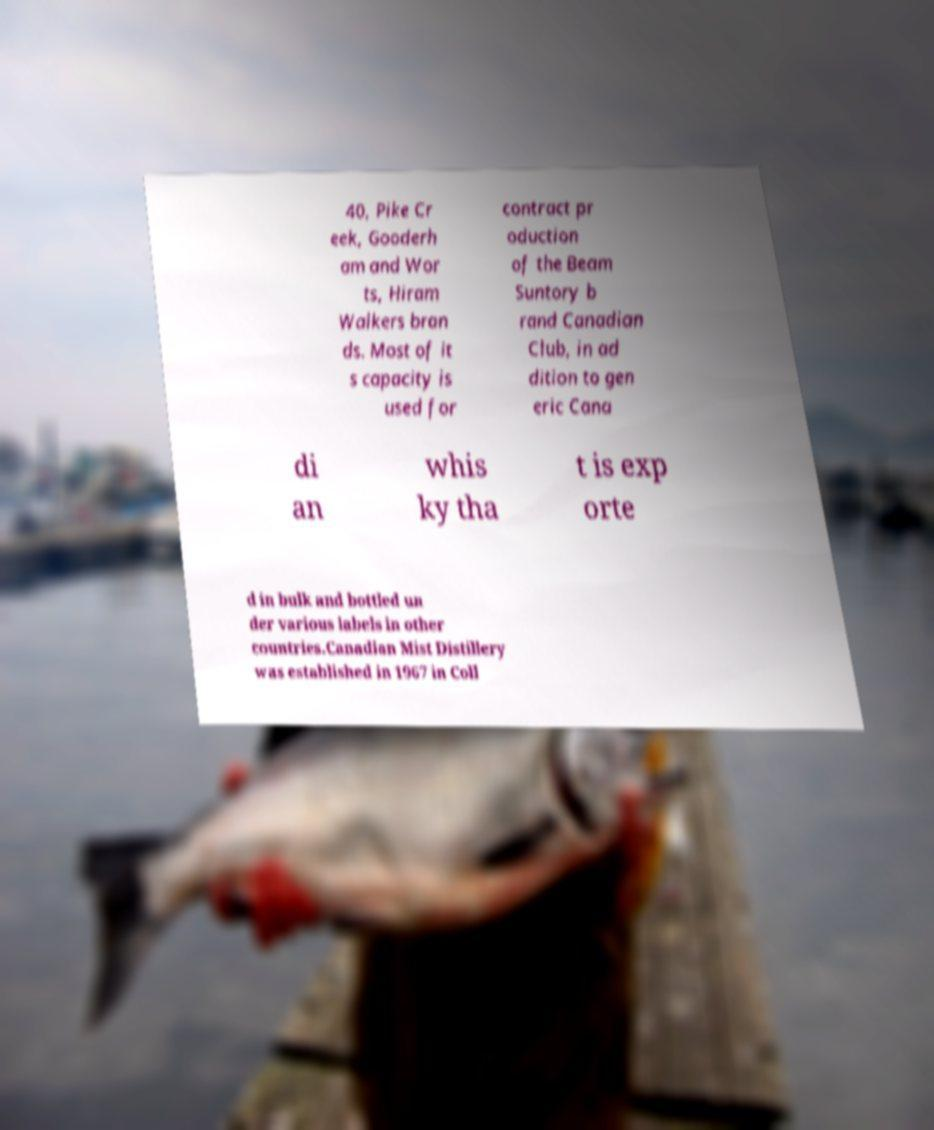There's text embedded in this image that I need extracted. Can you transcribe it verbatim? 40, Pike Cr eek, Gooderh am and Wor ts, Hiram Walkers bran ds. Most of it s capacity is used for contract pr oduction of the Beam Suntory b rand Canadian Club, in ad dition to gen eric Cana di an whis ky tha t is exp orte d in bulk and bottled un der various labels in other countries.Canadian Mist Distillery was established in 1967 in Coll 